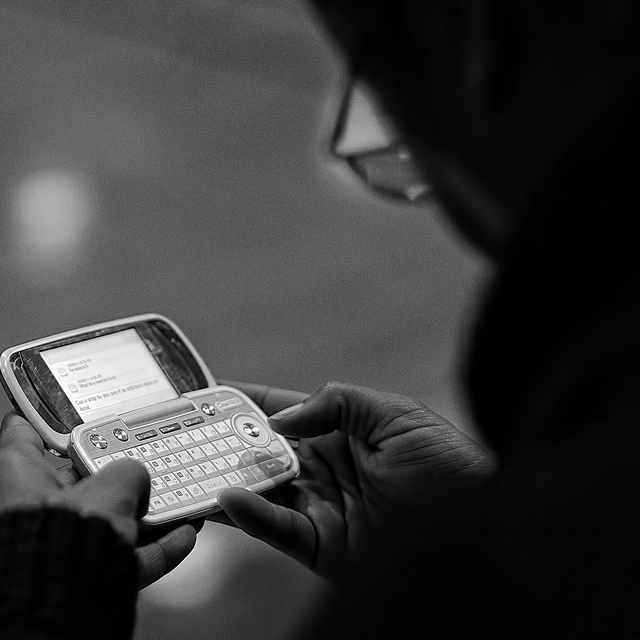Describe the objects in this image and their specific colors. I can see people in gray, black, darkgray, and lightgray tones and cell phone in gray, gainsboro, darkgray, and black tones in this image. 